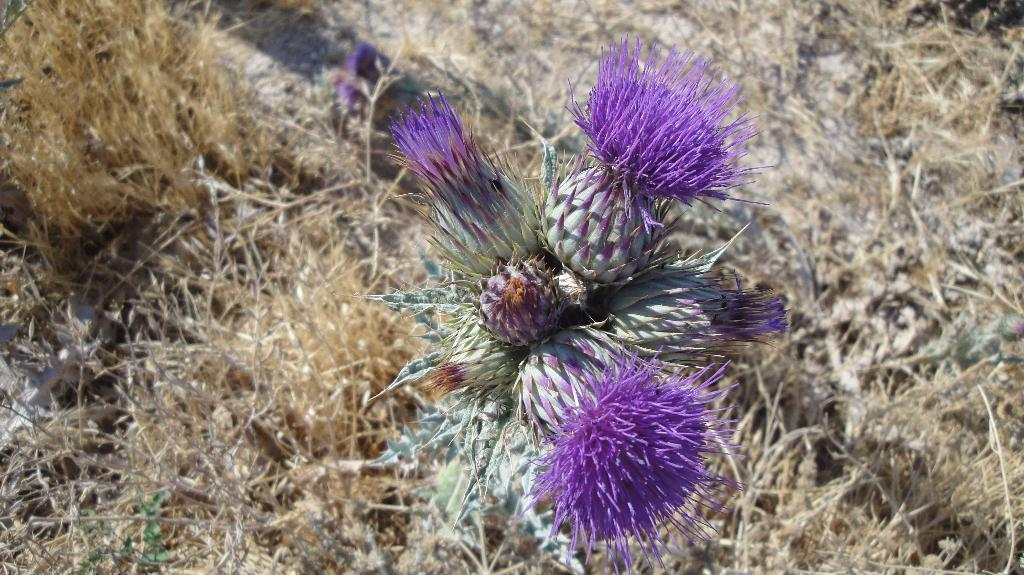What type of living organisms can be seen in the image? Plants can be seen in the image. What is the color of the flowers on the plants in the image? There are purple-colored flowers in the image. What direction is the pail facing in the image? There is no pail present in the image. What type of dish is being prepared in the image? The image does not show any dish being prepared, such as stew. 